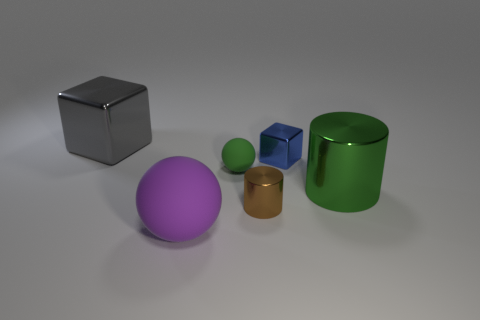What number of things are either things that are on the right side of the gray cube or blue shiny things?
Your answer should be compact. 5. Does the small thing that is in front of the large metal cylinder have the same color as the tiny matte sphere?
Give a very brief answer. No. What number of other things are the same color as the tiny rubber thing?
Make the answer very short. 1. What number of big things are either gray shiny cubes or green metal cylinders?
Offer a very short reply. 2. Are there more gray rubber things than large shiny blocks?
Keep it short and to the point. No. Do the blue thing and the big cube have the same material?
Provide a succinct answer. Yes. Are there any other things that have the same material as the green sphere?
Offer a terse response. Yes. Are there more big green metallic cylinders left of the brown shiny object than tiny metallic blocks?
Offer a terse response. No. Do the large cube and the tiny block have the same color?
Keep it short and to the point. No. What number of other big gray shiny objects have the same shape as the big gray metallic thing?
Provide a succinct answer. 0. 